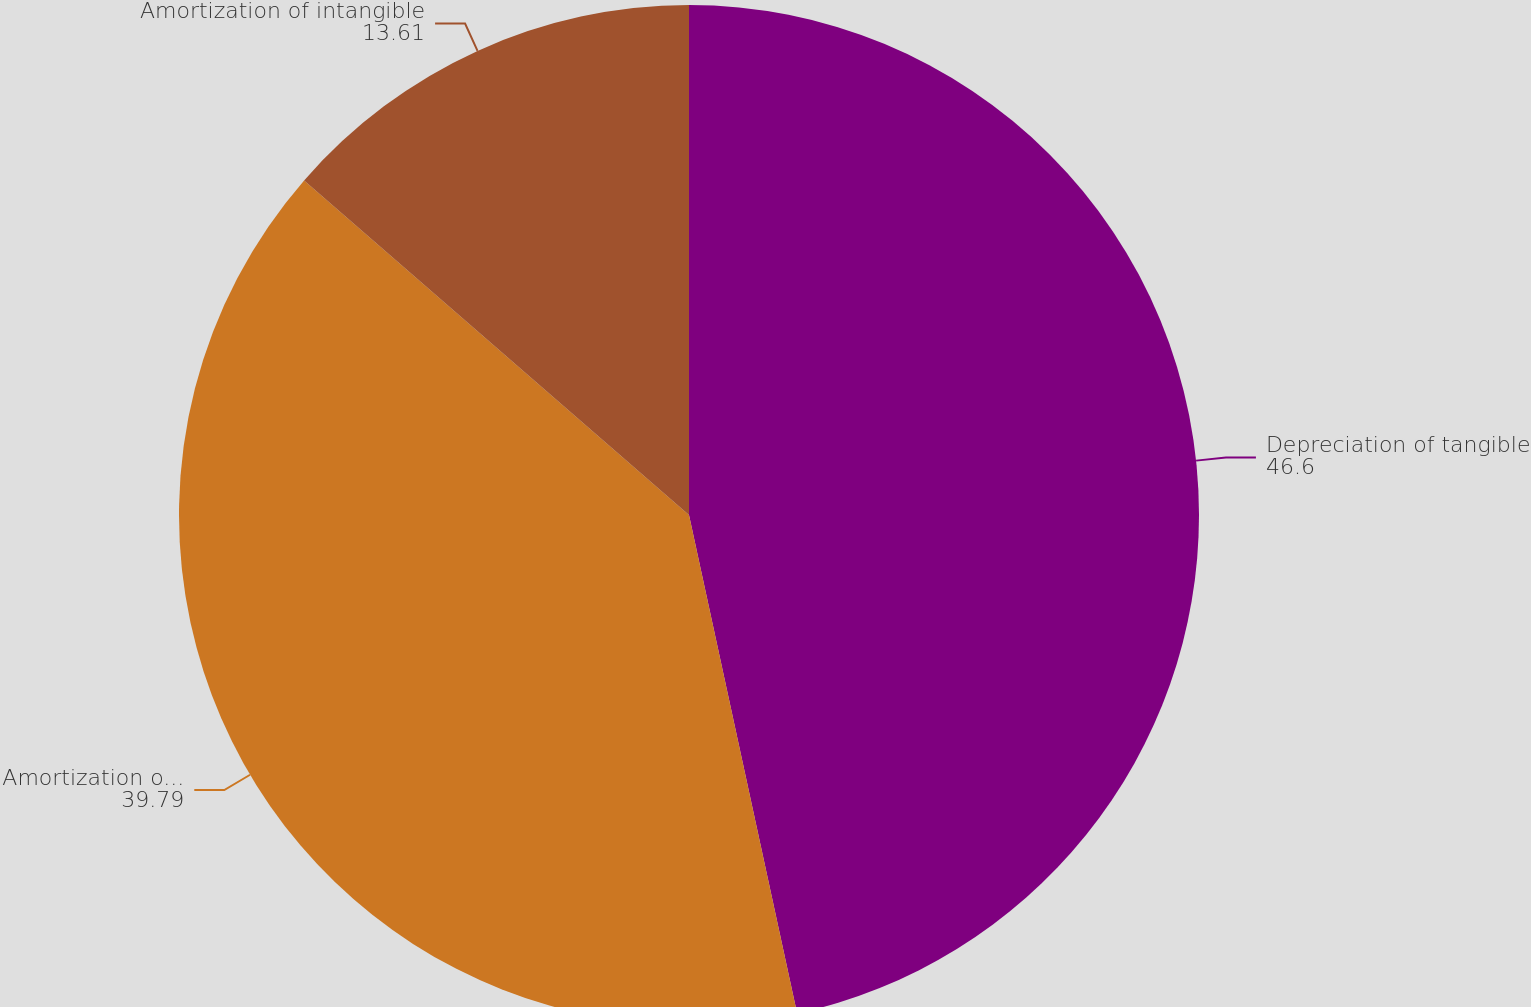Convert chart. <chart><loc_0><loc_0><loc_500><loc_500><pie_chart><fcel>Depreciation of tangible<fcel>Amortization of landfill<fcel>Amortization of intangible<nl><fcel>46.6%<fcel>39.79%<fcel>13.61%<nl></chart> 